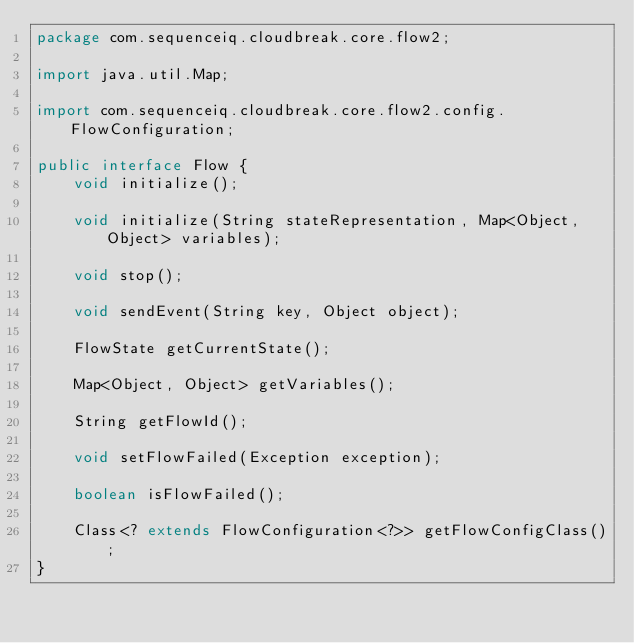Convert code to text. <code><loc_0><loc_0><loc_500><loc_500><_Java_>package com.sequenceiq.cloudbreak.core.flow2;

import java.util.Map;

import com.sequenceiq.cloudbreak.core.flow2.config.FlowConfiguration;

public interface Flow {
    void initialize();

    void initialize(String stateRepresentation, Map<Object, Object> variables);

    void stop();

    void sendEvent(String key, Object object);

    FlowState getCurrentState();

    Map<Object, Object> getVariables();

    String getFlowId();

    void setFlowFailed(Exception exception);

    boolean isFlowFailed();

    Class<? extends FlowConfiguration<?>> getFlowConfigClass();
}
</code> 